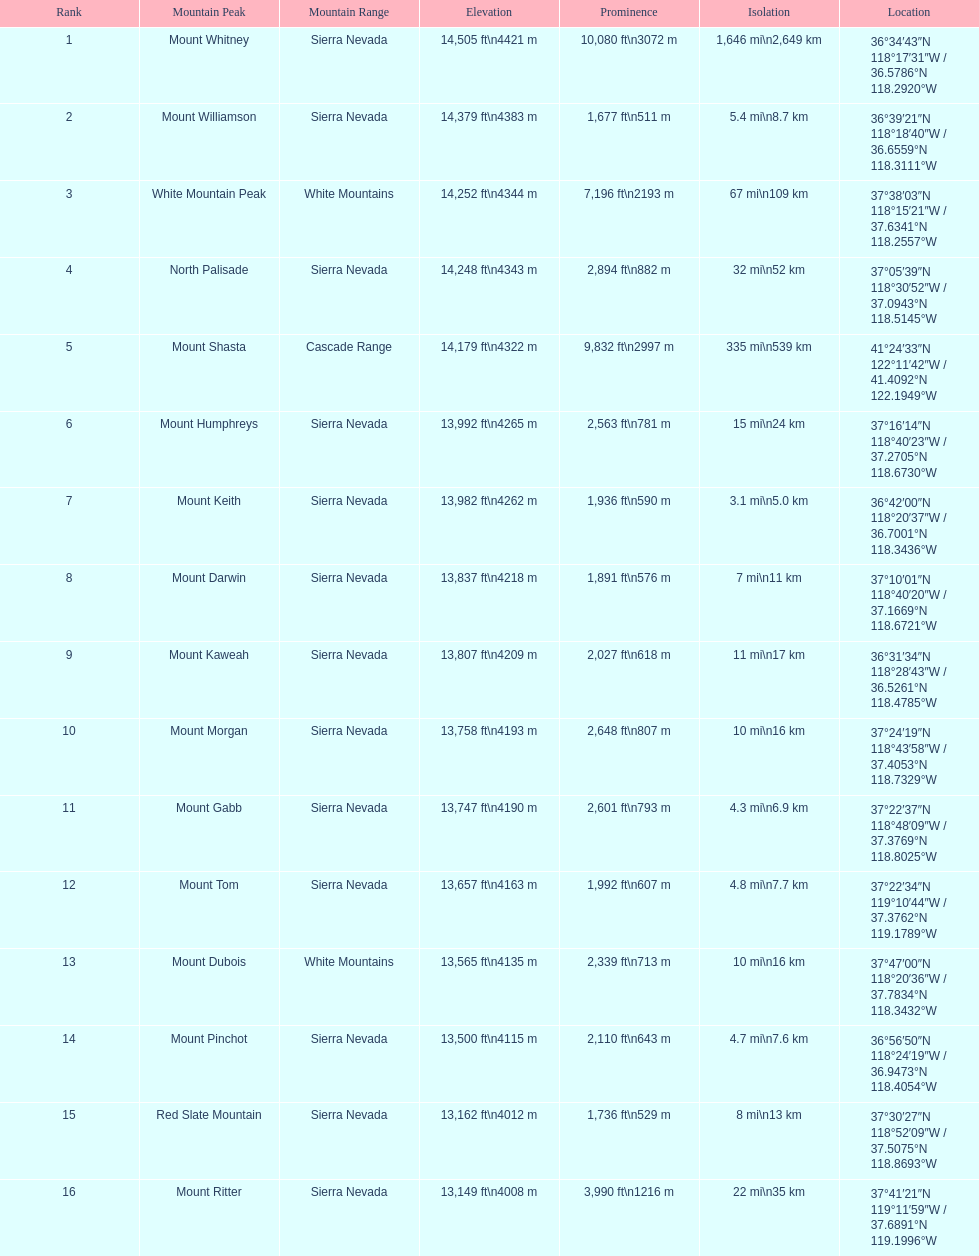What is the difference in height, in feet, between the highest and the 9th highest peak in california? 698 ft. 